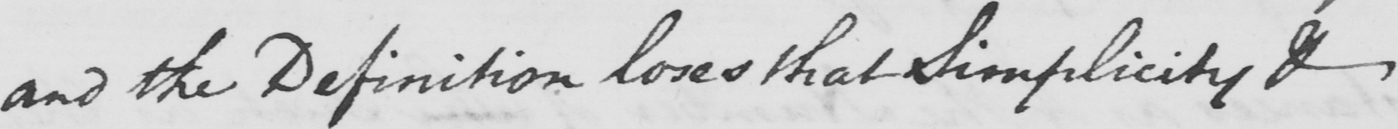What text is written in this handwritten line? and the Definition loses that Simplicity & 